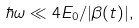Convert formula to latex. <formula><loc_0><loc_0><loc_500><loc_500>\hbar { \omega } \ll 4 E _ { 0 } / | \beta ( t ) | ,</formula> 